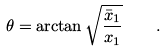<formula> <loc_0><loc_0><loc_500><loc_500>\theta = \arctan { \sqrt { \frac { \bar { x } _ { 1 } } { x _ { 1 } } } } \quad .</formula> 